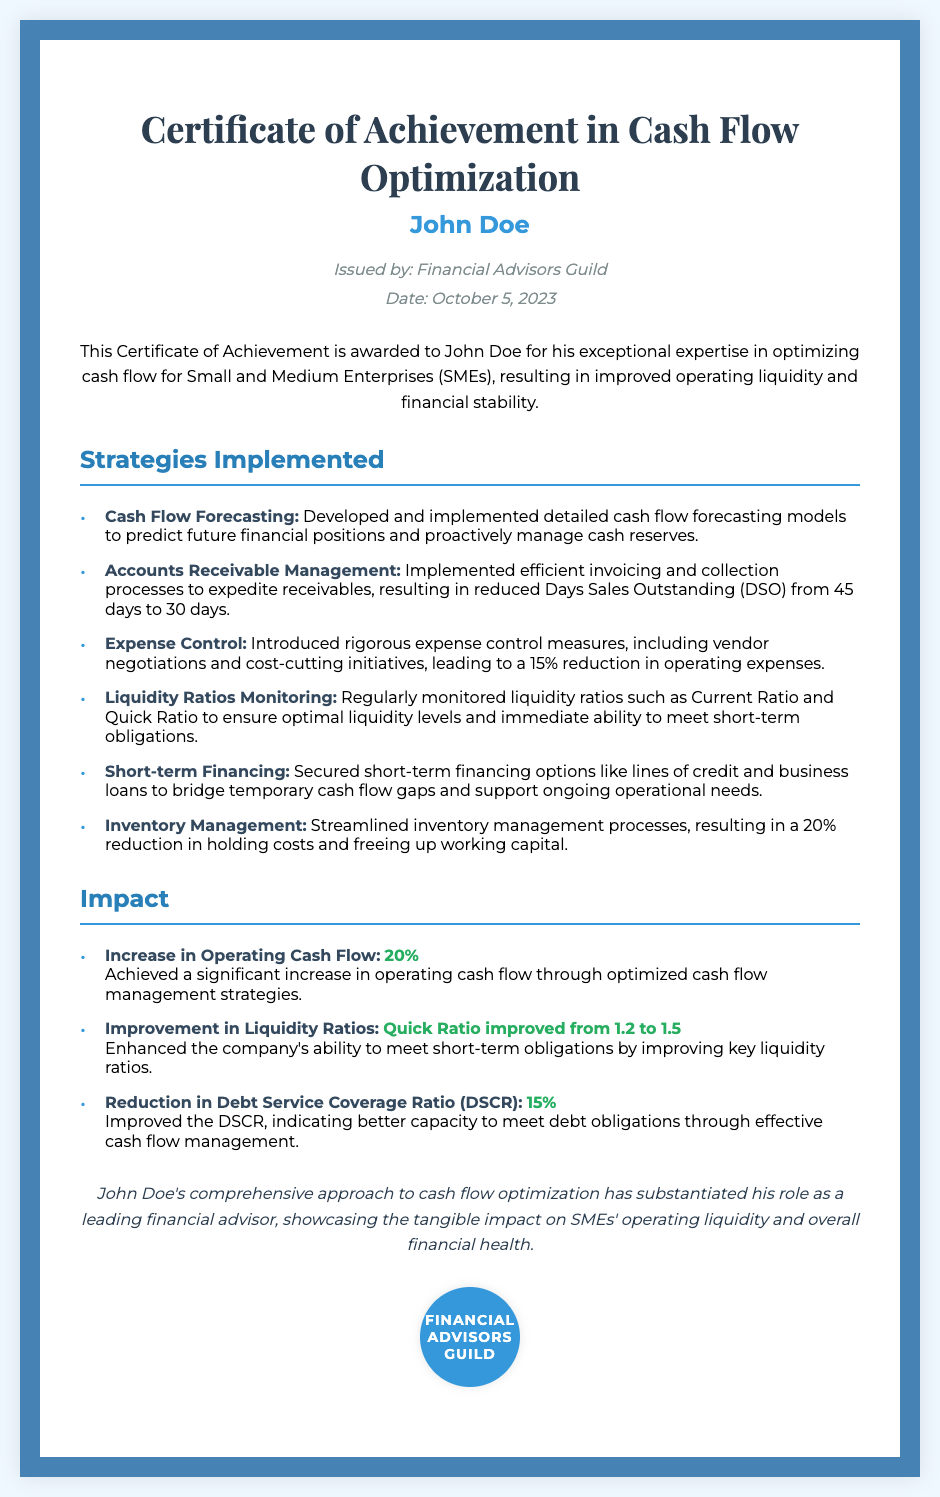What is the name of the recipient? The name of the recipient is specified at the top of the certificate.
Answer: John Doe Who issued the certificate? The issuer of the certificate is mentioned below the recipient's name.
Answer: Financial Advisors Guild What date was the certificate issued? The date of issuance is clearly stated within the document.
Answer: October 5, 2023 What strategy reduced Days Sales Outstanding (DSO)? The strategy that resulted in reduced DSO is highlighted in the strategies section.
Answer: Accounts Receivable Management By what percentage were operating expenses reduced? The impact of the expense control measures is noted in the strategies section.
Answer: 15% What is the value of the Quick Ratio after optimization? The improved Quick Ratio is clearly mentioned in the impact section.
Answer: 1.5 What was the percentage increase in operating cash flow? The increase in operating cash flow is detailed in the impact section.
Answer: 20% Which strategy led to a reduction in holding costs? The strategy that contributed to reduced holding costs is listed in the strategies section.
Answer: Inventory Management What is the conclusion regarding John Doe's contributions? The conclusion summarizes John Doe's role and impact in the certificate.
Answer: Comprehensive approach to cash flow optimization 